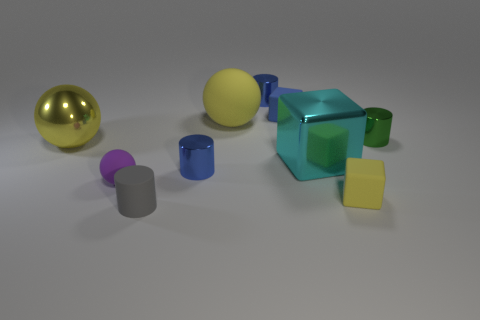How many yellow balls must be subtracted to get 1 yellow balls? 1 Subtract all cyan blocks. How many blocks are left? 2 Subtract all green blocks. How many yellow balls are left? 2 Subtract all green cylinders. How many cylinders are left? 3 Subtract 1 cubes. How many cubes are left? 2 Subtract all cubes. How many objects are left? 7 Subtract all purple blocks. Subtract all purple spheres. How many blocks are left? 3 Subtract all small purple matte things. Subtract all big metal blocks. How many objects are left? 8 Add 4 small gray things. How many small gray things are left? 5 Add 6 rubber cylinders. How many rubber cylinders exist? 7 